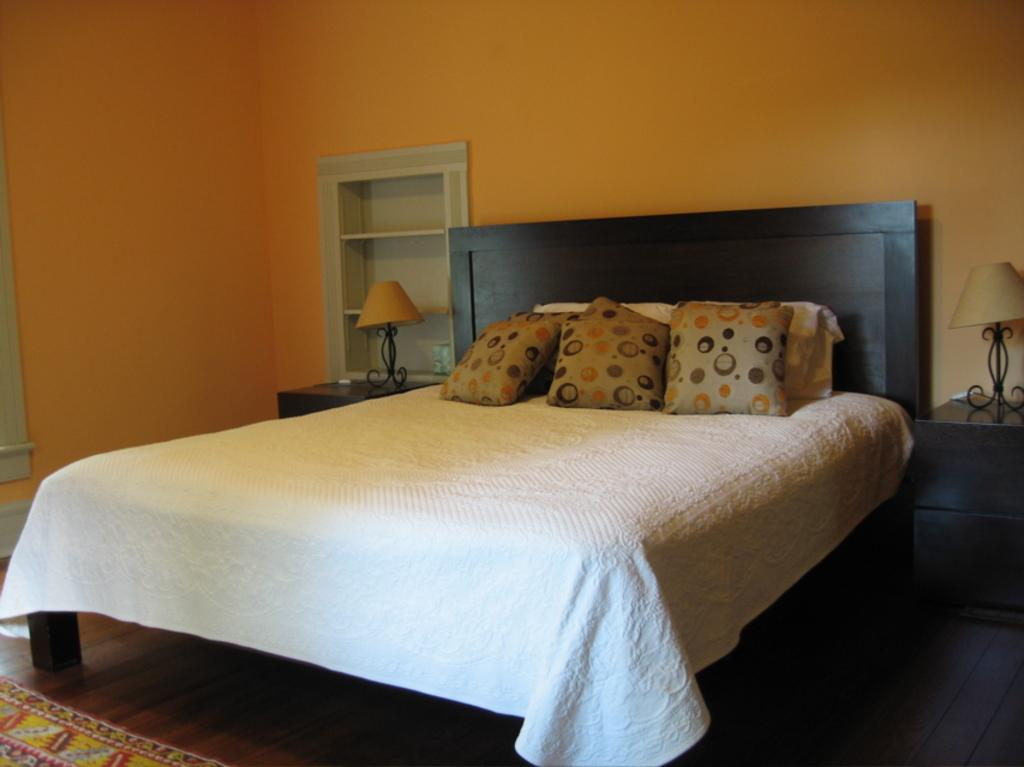What can be seen on the bed in the image? There are pillows on the bed. What objects are on tables in the image? There are lamps on tables in the image. What is visible on the wall in the image? The wall is visible in the image. What type of surface is visible beneath the bed and tables? There is a floor visible in the image. How many chairs are present in the image? There is no mention of chairs in the provided facts, so we cannot determine the number of chairs in the image. Is there a baby visible in the image? There is no mention of a baby in the provided facts, so we cannot determine if a baby is present in the image. 